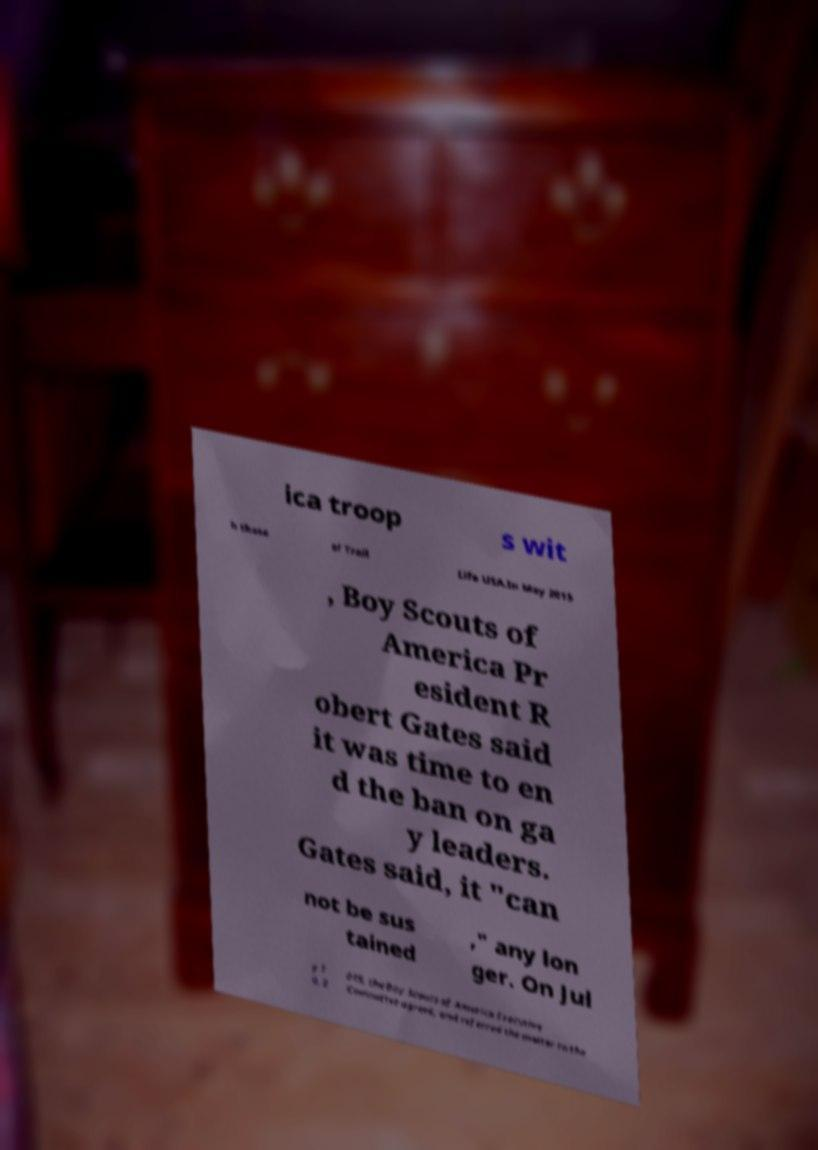Could you extract and type out the text from this image? ica troop s wit h those of Trail Life USA.In May 2015 , Boy Scouts of America Pr esident R obert Gates said it was time to en d the ban on ga y leaders. Gates said, it "can not be sus tained ," any lon ger. On Jul y 1 0, 2 015, the Boy Scouts of America Executive Committee agreed, and referred the matter to the 